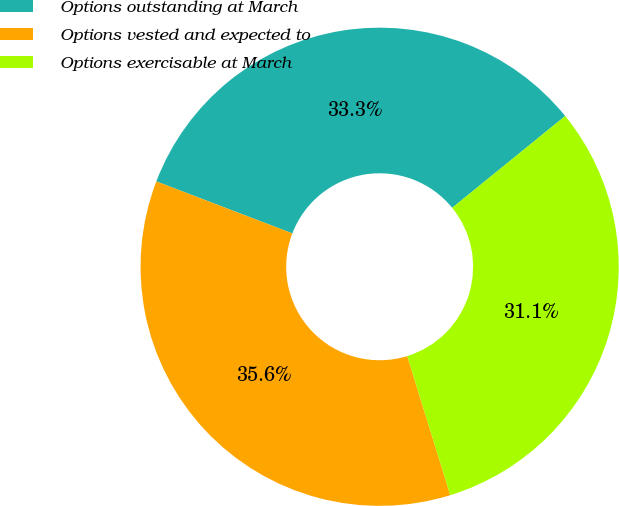<chart> <loc_0><loc_0><loc_500><loc_500><pie_chart><fcel>Options outstanding at March<fcel>Options vested and expected to<fcel>Options exercisable at March<nl><fcel>33.33%<fcel>35.58%<fcel>31.08%<nl></chart> 